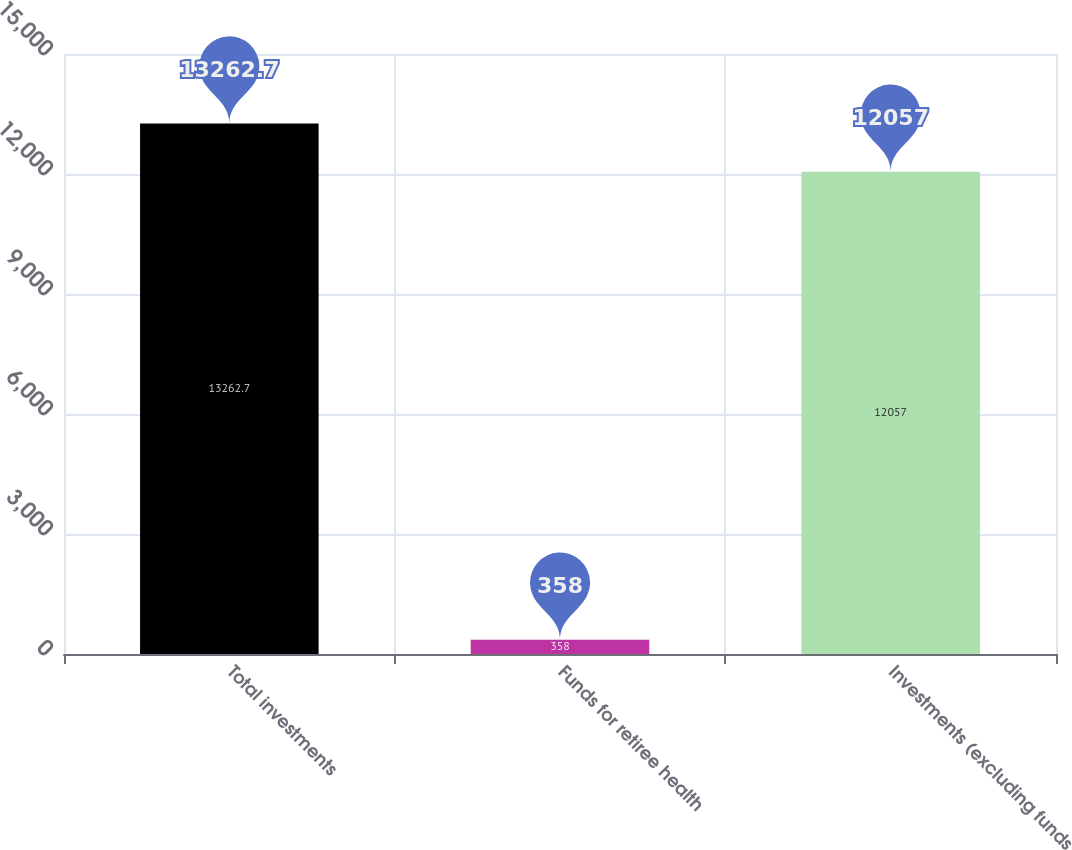Convert chart to OTSL. <chart><loc_0><loc_0><loc_500><loc_500><bar_chart><fcel>Total investments<fcel>Funds for retiree health<fcel>Investments (excluding funds<nl><fcel>13262.7<fcel>358<fcel>12057<nl></chart> 